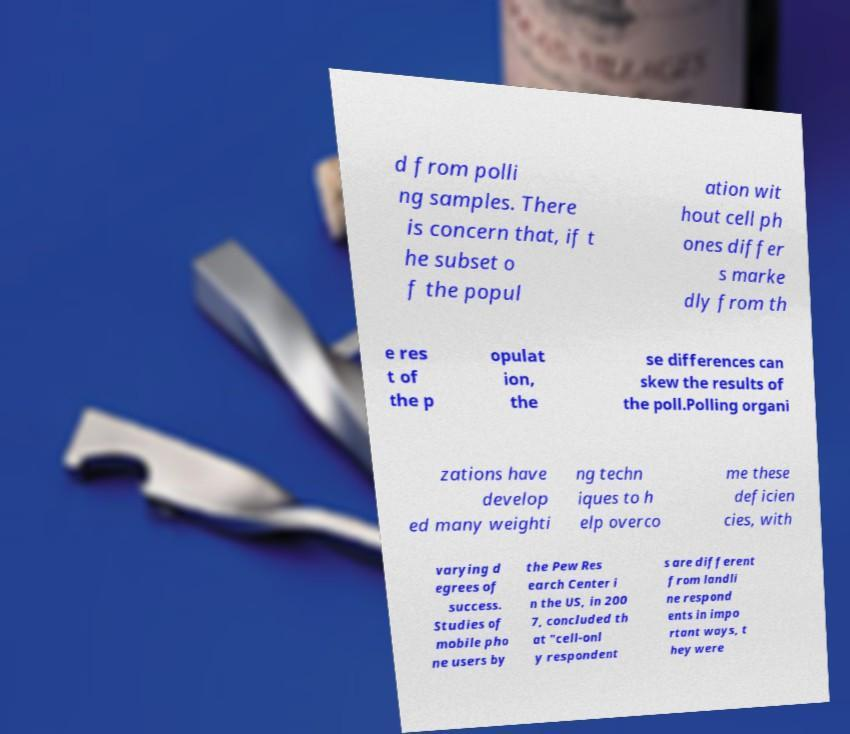There's text embedded in this image that I need extracted. Can you transcribe it verbatim? d from polli ng samples. There is concern that, if t he subset o f the popul ation wit hout cell ph ones differ s marke dly from th e res t of the p opulat ion, the se differences can skew the results of the poll.Polling organi zations have develop ed many weighti ng techn iques to h elp overco me these deficien cies, with varying d egrees of success. Studies of mobile pho ne users by the Pew Res earch Center i n the US, in 200 7, concluded th at "cell-onl y respondent s are different from landli ne respond ents in impo rtant ways, t hey were 